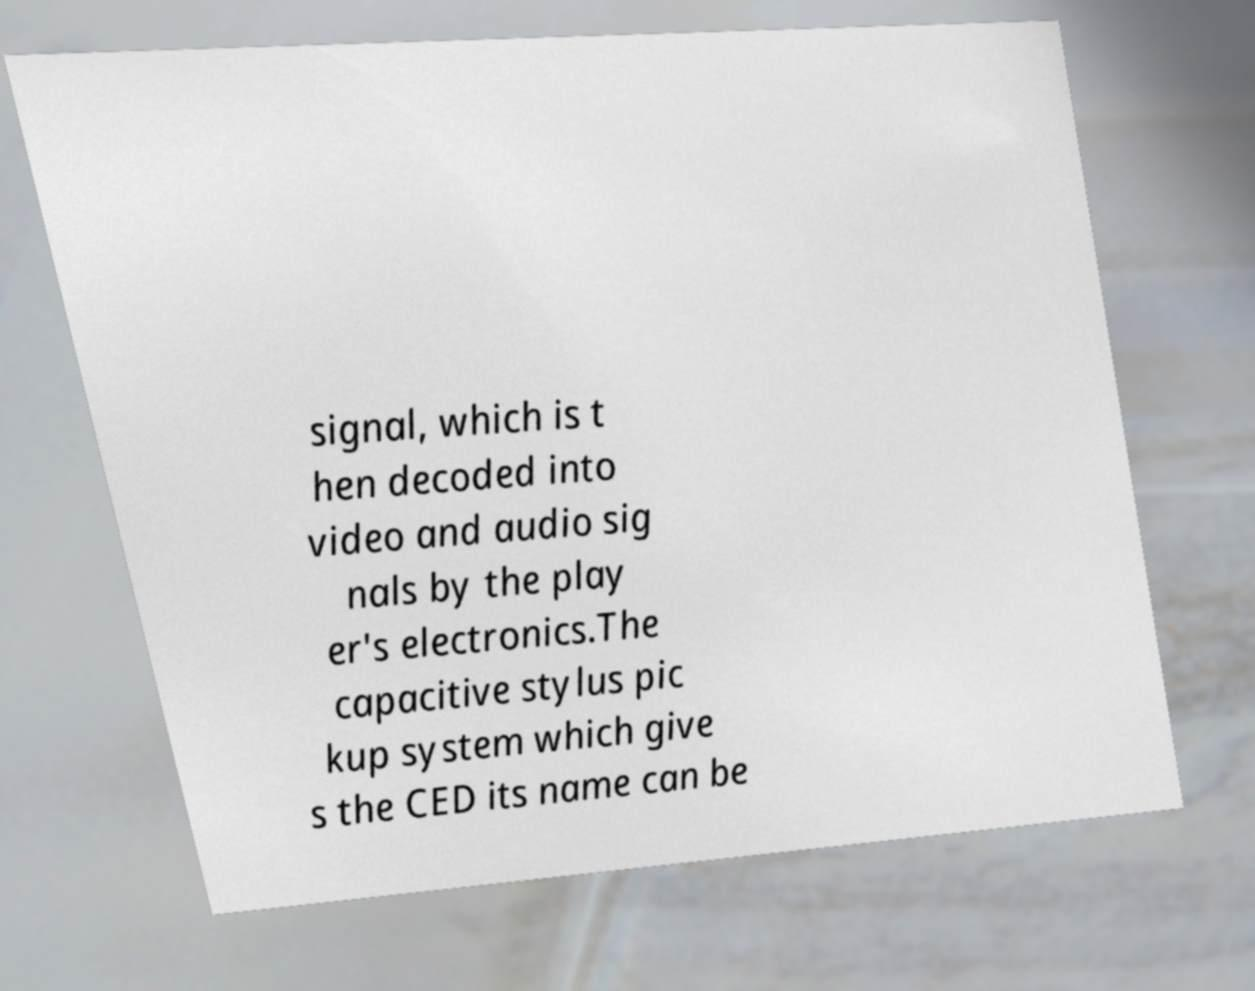Can you read and provide the text displayed in the image?This photo seems to have some interesting text. Can you extract and type it out for me? signal, which is t hen decoded into video and audio sig nals by the play er's electronics.The capacitive stylus pic kup system which give s the CED its name can be 